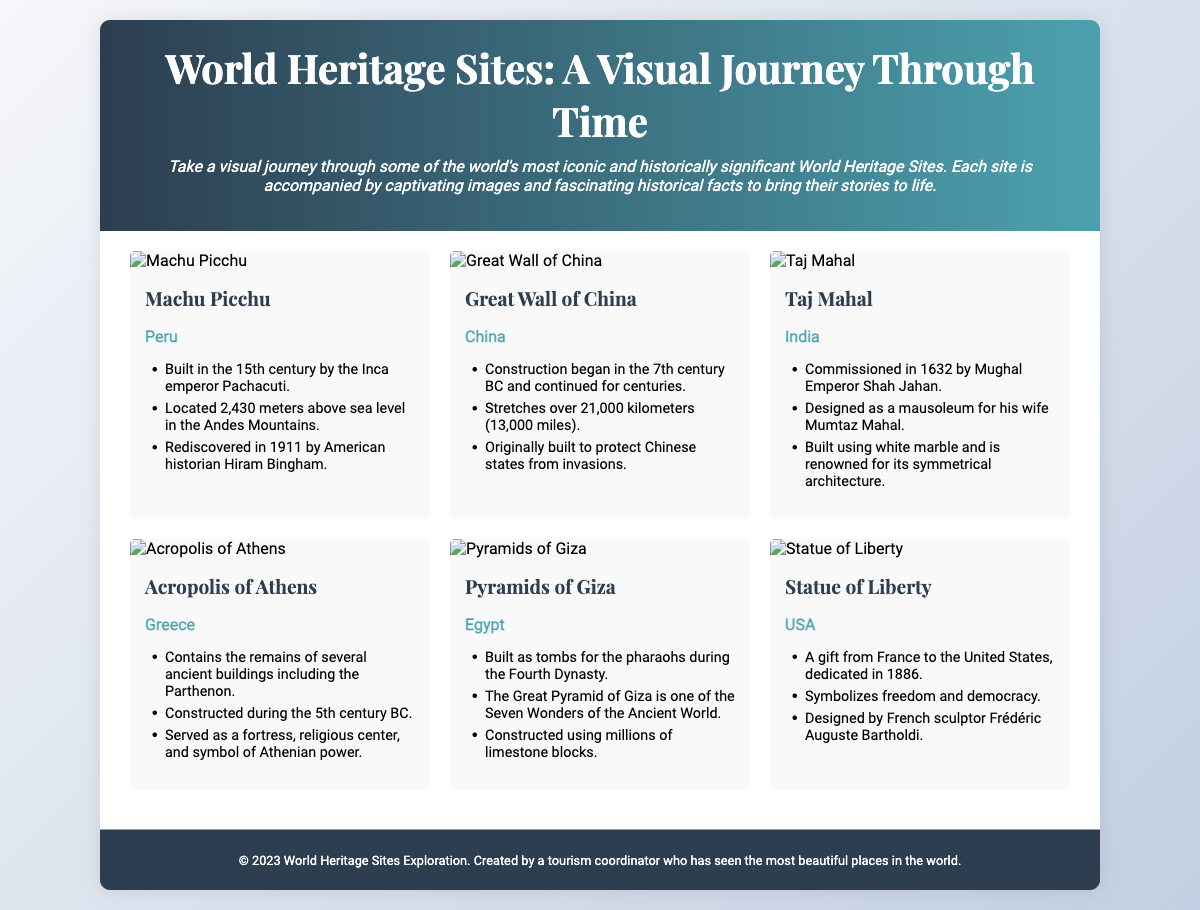What is the name of the site located in Peru? The document lists Machu Picchu as the site located in Peru.
Answer: Machu Picchu When was the Taj Mahal commissioned? The document states that the Taj Mahal was commissioned in 1632 by Mughal Emperor Shah Jahan.
Answer: 1632 What is the height of Machu Picchu above sea level? The document mentions that Machu Picchu is located 2,430 meters above sea level.
Answer: 2,430 meters Which site is known as a symbol of freedom and democracy? According to the document, the Statue of Liberty symbolizes freedom and democracy.
Answer: Statue of Liberty How many kilometers does the Great Wall of China stretch? The document states that the Great Wall of China stretches over 21,000 kilometers.
Answer: 21,000 kilometers Which ancient wonder is mentioned in relation to the Pyramids of Giza? The document refers to the Great Pyramid of Giza as one of the Seven Wonders of the Ancient World.
Answer: Seven Wonders of the Ancient World What century was the Acropolis of Athens constructed in? The document indicates that the Acropolis of Athens was constructed during the 5th century BC.
Answer: 5th century BC What year was the Statue of Liberty dedicated? The document states that the Statue of Liberty was dedicated in 1886.
Answer: 1886 